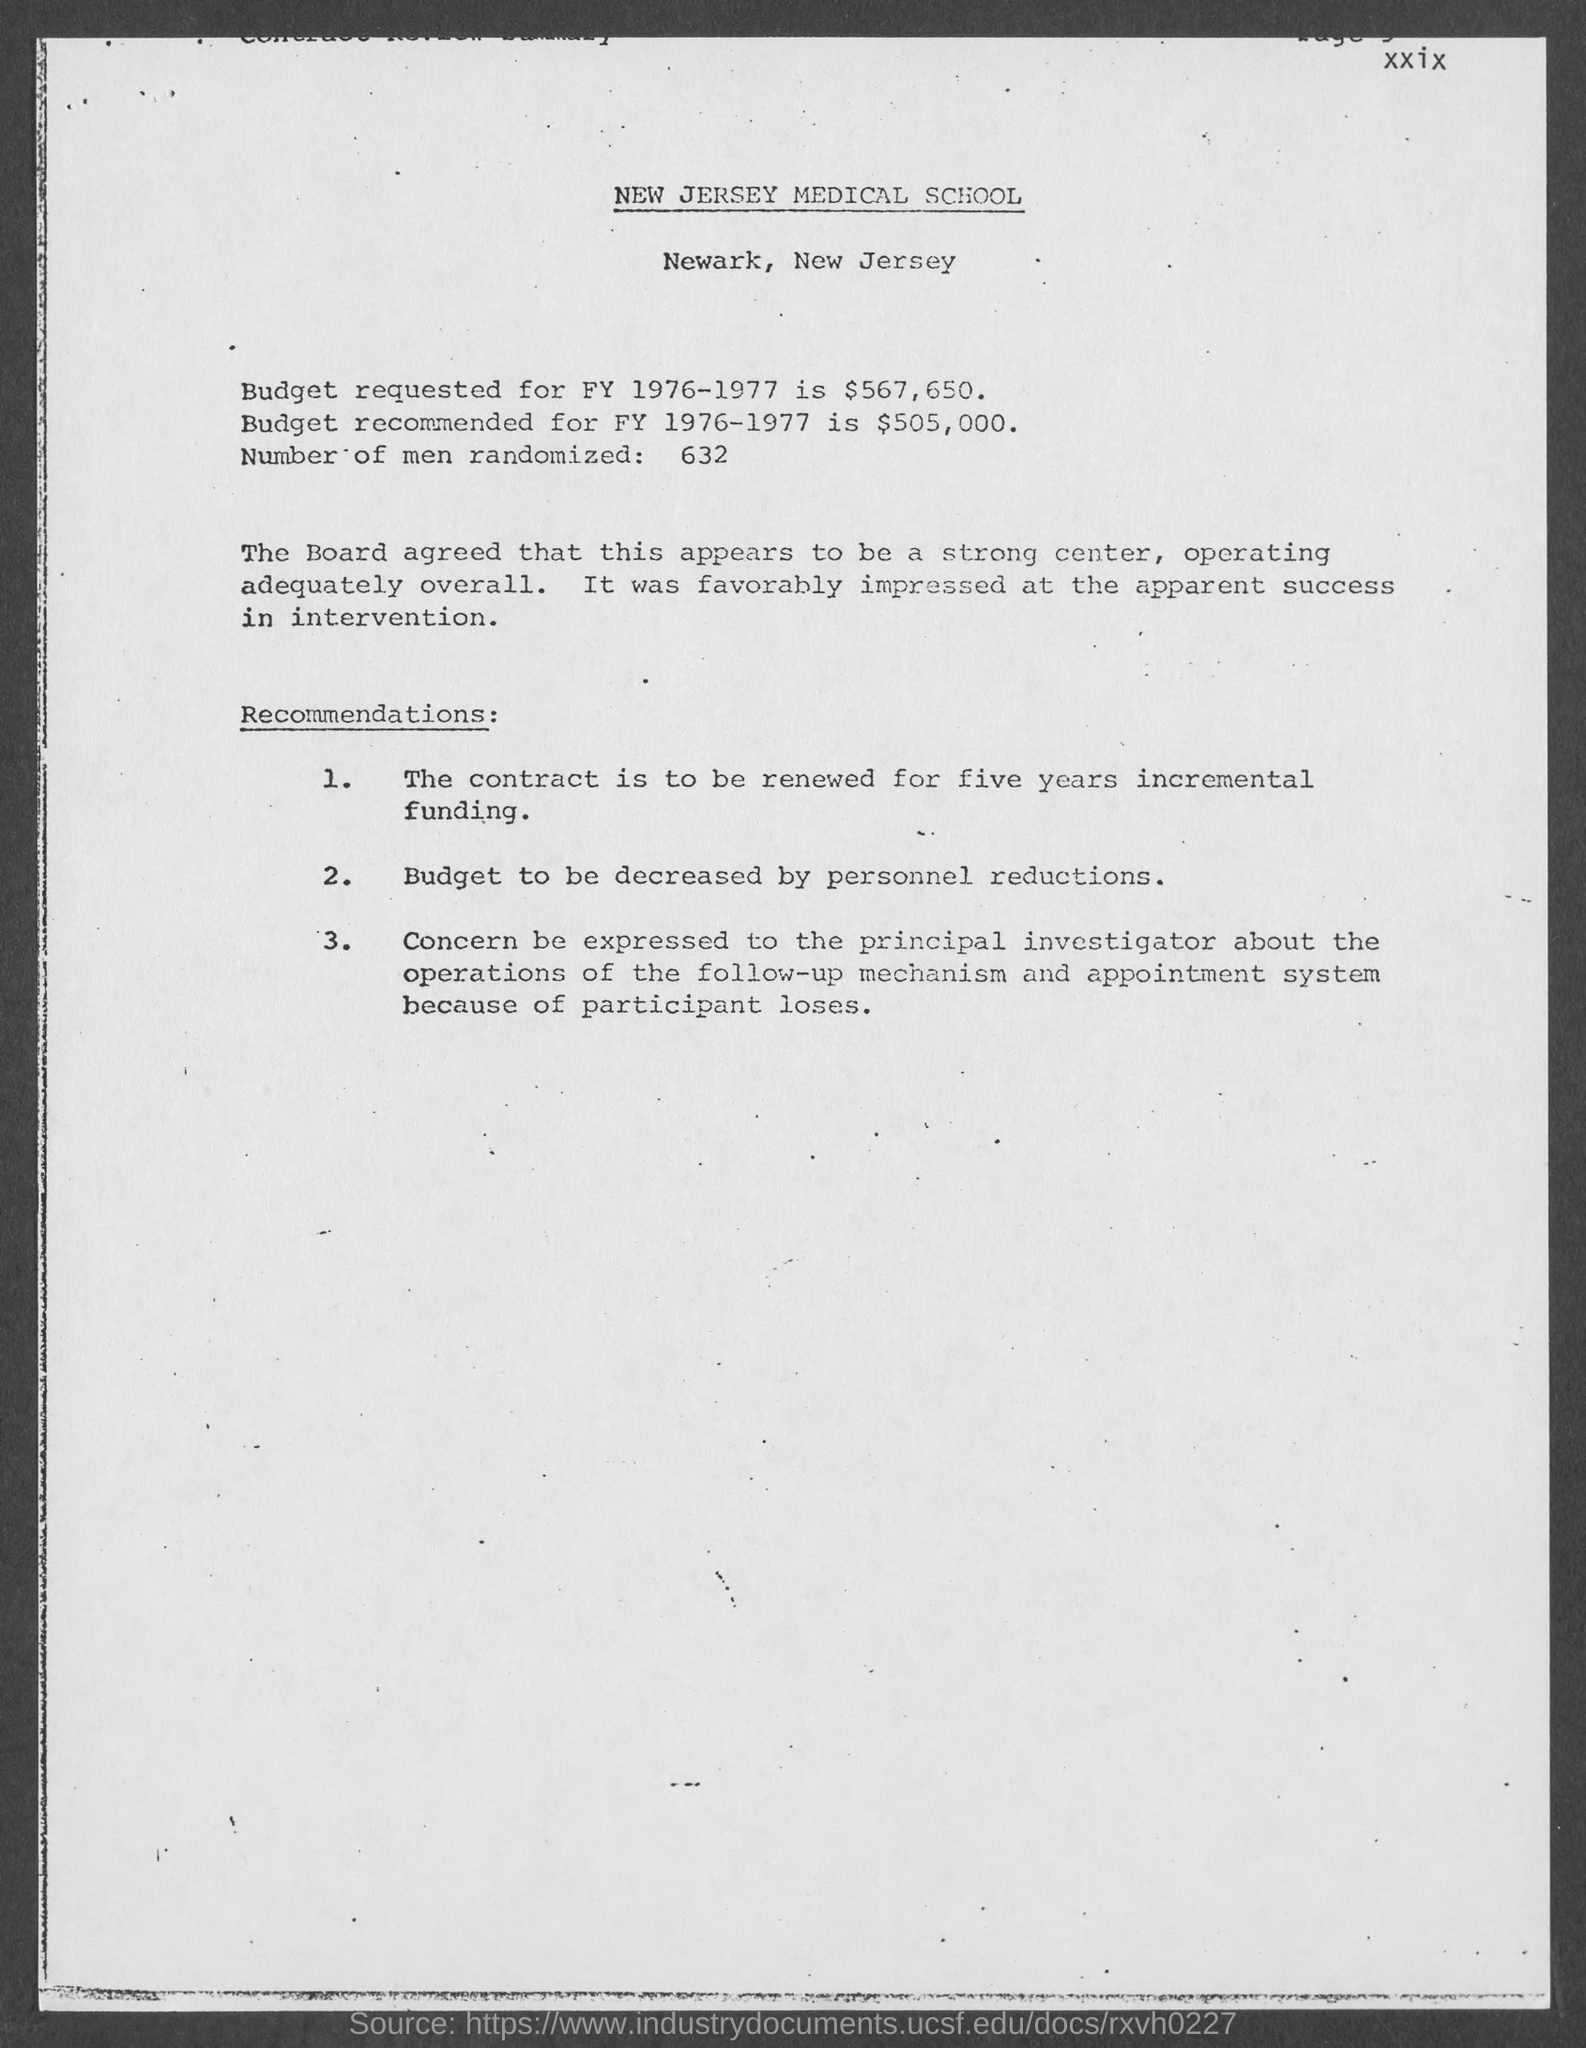What does the document suggest about the future of the contract mentioned? The document recommends renewing the contract for an incremental five years, indicating a favorable assessment of the center's performance and its continued relevance to ongoing projects or research. 